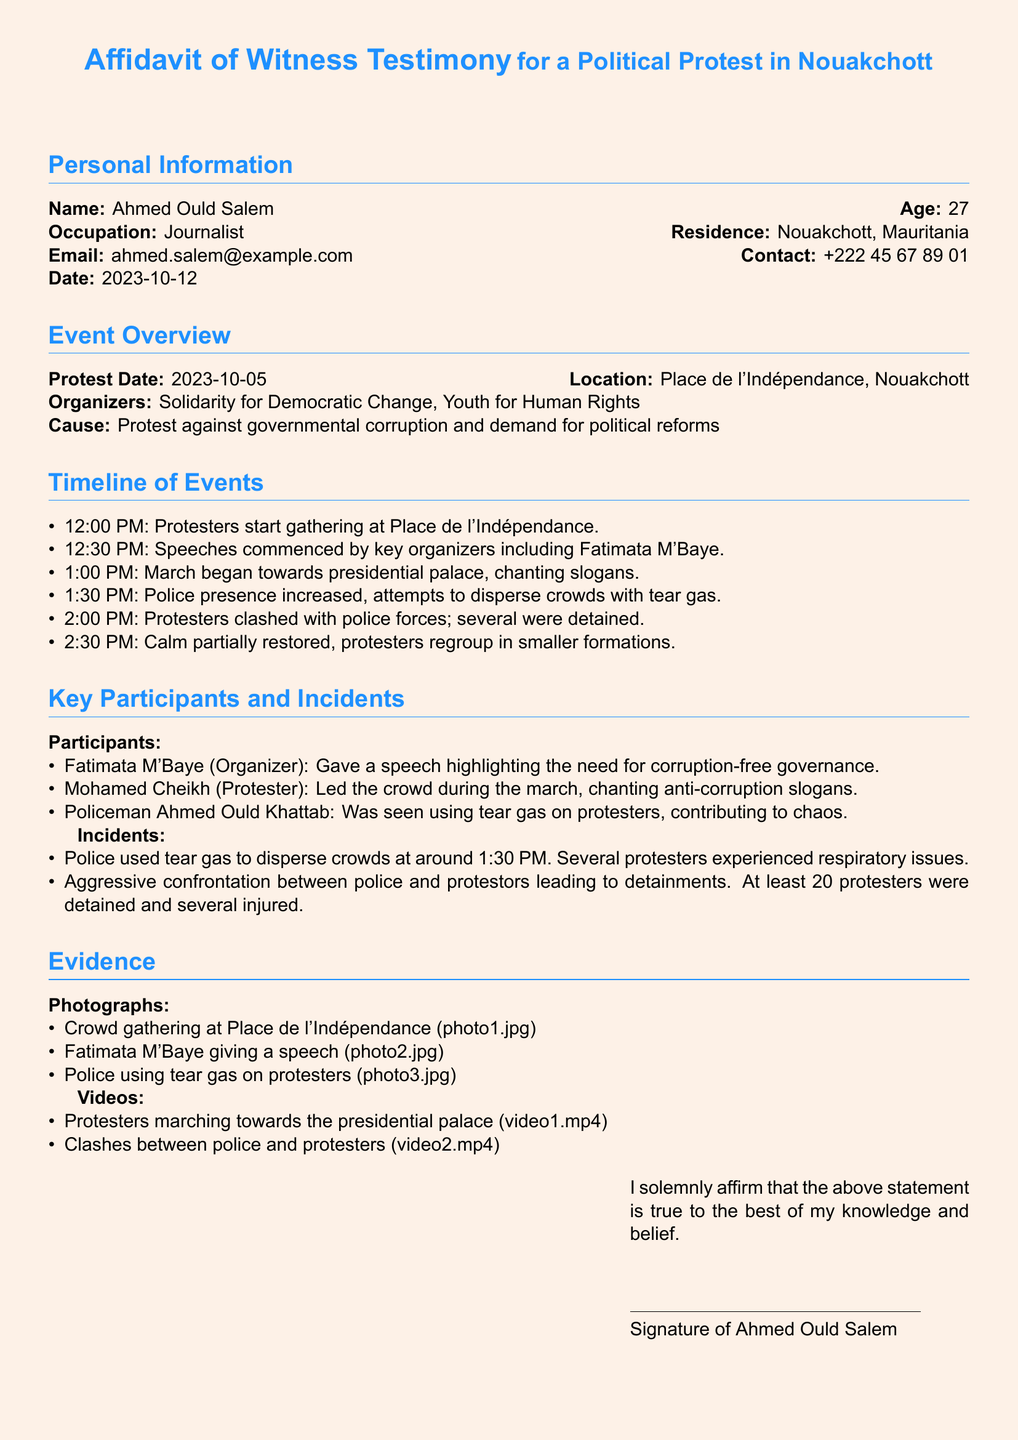What is the name of the witness? The witness is identified in the personal information section of the document as Ahmed Ould Salem.
Answer: Ahmed Ould Salem What is the age of the witness? The age of the witness is explicitly stated in the personal information section.
Answer: 27 On what date did the protest occur? The date of the protest is mentioned under the event overview.
Answer: 2023-10-05 Who organized the protest? The organizers are listed in the event overview section.
Answer: Solidarity for Democratic Change, Youth for Human Rights What time did the police attempt to disperse the crowd? The timeline specifies the time of police actions during the protest.
Answer: 1:30 PM How many protesters were detained according to the affidavit? The document states the number of detained protesters in the section on incidents.
Answer: 20 What was the main cause of the protest? The cause of the protest is detailed under the event overview.
Answer: Protest against governmental corruption and demand for political reforms Who was seen using tear gas on protesters? The key participants and incidents section identifies a specific policeman responsible for this action.
Answer: Policeman Ahmed Ould Khattab What evidence is provided to support the witness testimony? The affidavit lists types of evidence collected during the protest related to the testimony.
Answer: Photographs and videos 